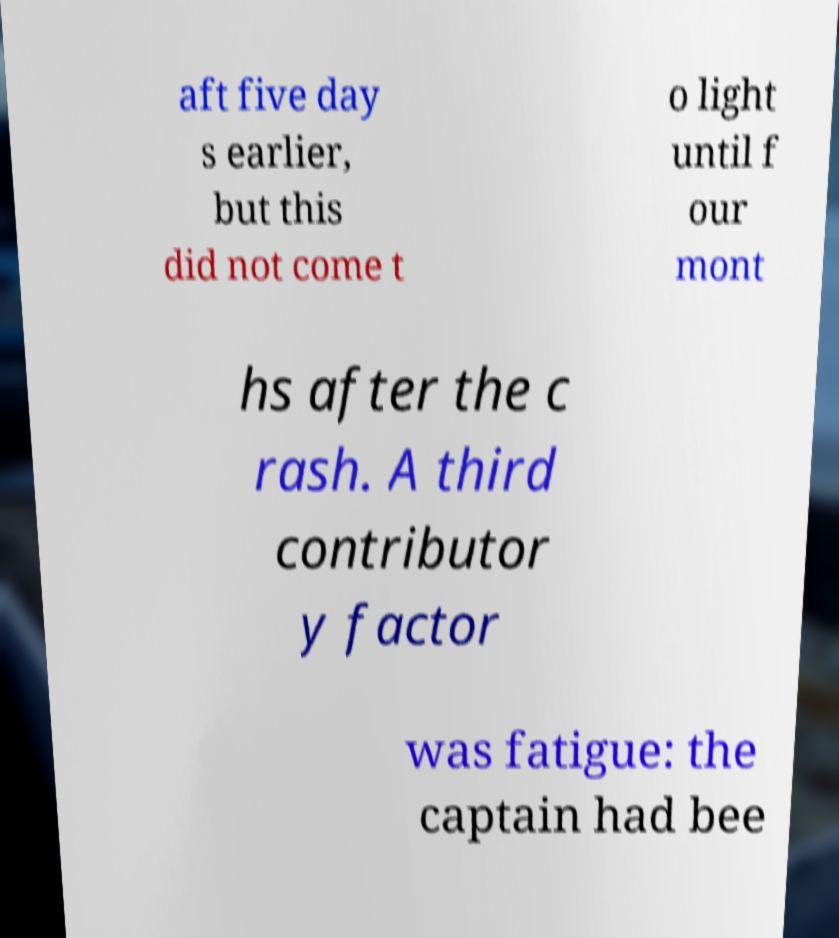For documentation purposes, I need the text within this image transcribed. Could you provide that? aft five day s earlier, but this did not come t o light until f our mont hs after the c rash. A third contributor y factor was fatigue: the captain had bee 